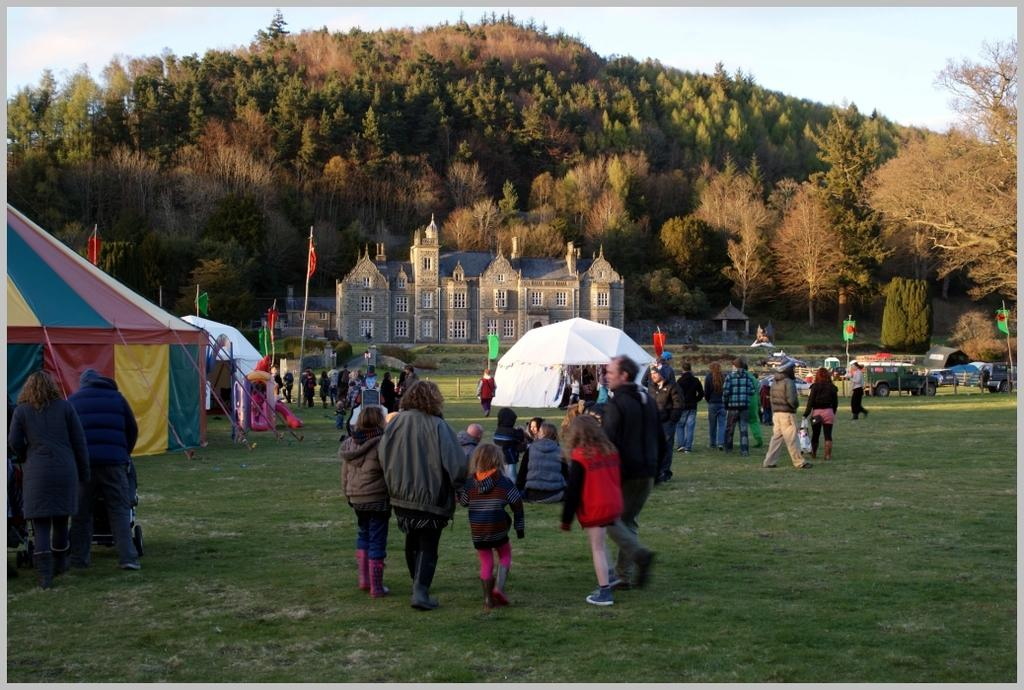What is the main activity of the people in the image? The group of people in the image is on the grass, which suggests they might be engaged in an outdoor activity or gathering. What structures can be seen in the image? There are tents and a building with windows in the image. What type of vehicles are present in the image? Vehicles are present in the image, but their specific types are not mentioned. What can be seen in the background of the image? The sky is visible in the background of the image. What other objects are present in the image? There are flags, trees, and some unspecified objects in the image. How far away is the zebra from the group of people in the image? There is no zebra present in the image, so it is not possible to determine its distance from the group of people. What type of home is visible in the image? The image does not show a home; it features a building with windows, but the purpose or type of structure is not specified. 